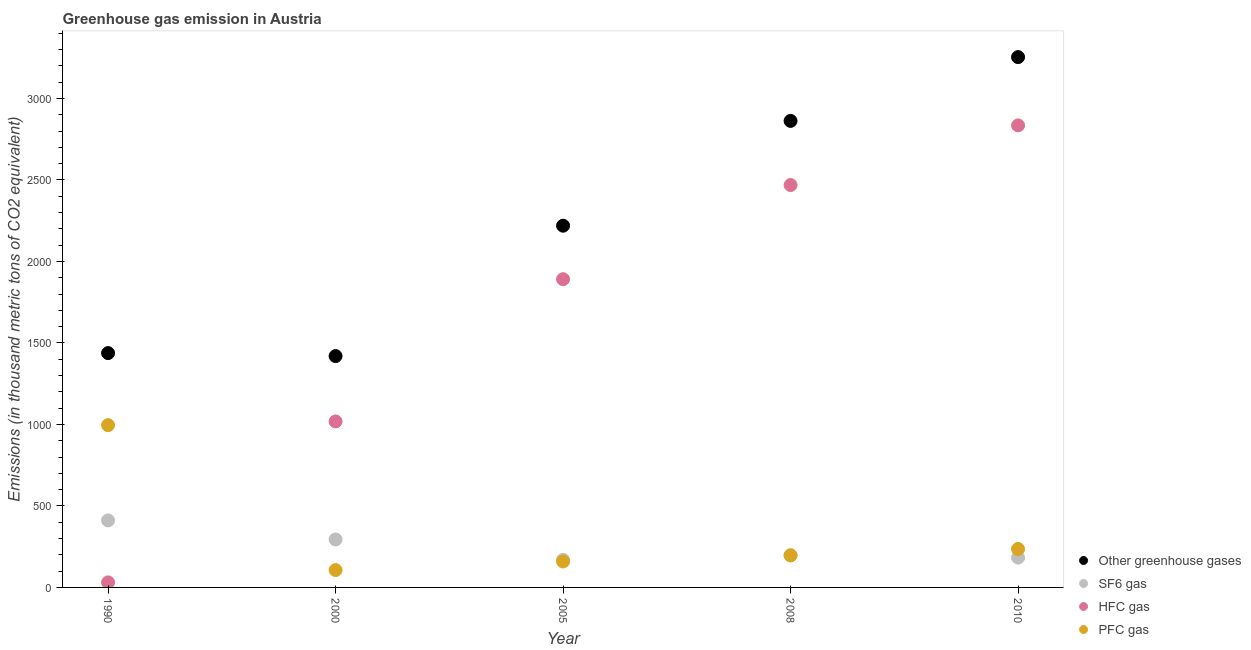What is the emission of sf6 gas in 2010?
Your answer should be very brief. 183. Across all years, what is the maximum emission of sf6 gas?
Your response must be concise. 411.2. Across all years, what is the minimum emission of hfc gas?
Your response must be concise. 30.9. What is the total emission of greenhouse gases in the graph?
Your answer should be very brief. 1.12e+04. What is the difference between the emission of sf6 gas in 2000 and that in 2005?
Offer a terse response. 125.4. What is the difference between the emission of sf6 gas in 2010 and the emission of hfc gas in 2000?
Your response must be concise. -835.4. What is the average emission of greenhouse gases per year?
Ensure brevity in your answer.  2238.64. In the year 2000, what is the difference between the emission of sf6 gas and emission of pfc gas?
Your response must be concise. 187.7. In how many years, is the emission of pfc gas greater than 2500 thousand metric tons?
Offer a very short reply. 0. What is the ratio of the emission of sf6 gas in 1990 to that in 2010?
Provide a succinct answer. 2.25. Is the difference between the emission of sf6 gas in 2008 and 2010 greater than the difference between the emission of hfc gas in 2008 and 2010?
Keep it short and to the point. Yes. What is the difference between the highest and the second highest emission of pfc gas?
Provide a short and direct response. 759.7. What is the difference between the highest and the lowest emission of hfc gas?
Provide a short and direct response. 2804.1. Is the sum of the emission of hfc gas in 2000 and 2005 greater than the maximum emission of greenhouse gases across all years?
Your response must be concise. No. Is it the case that in every year, the sum of the emission of greenhouse gases and emission of sf6 gas is greater than the emission of hfc gas?
Ensure brevity in your answer.  Yes. Does the emission of sf6 gas monotonically increase over the years?
Provide a succinct answer. No. Is the emission of hfc gas strictly less than the emission of pfc gas over the years?
Your response must be concise. No. How many dotlines are there?
Your answer should be very brief. 4. How many years are there in the graph?
Give a very brief answer. 5. Are the values on the major ticks of Y-axis written in scientific E-notation?
Ensure brevity in your answer.  No. How many legend labels are there?
Offer a terse response. 4. What is the title of the graph?
Your answer should be compact. Greenhouse gas emission in Austria. What is the label or title of the X-axis?
Your answer should be compact. Year. What is the label or title of the Y-axis?
Give a very brief answer. Emissions (in thousand metric tons of CO2 equivalent). What is the Emissions (in thousand metric tons of CO2 equivalent) of Other greenhouse gases in 1990?
Give a very brief answer. 1437.8. What is the Emissions (in thousand metric tons of CO2 equivalent) of SF6 gas in 1990?
Keep it short and to the point. 411.2. What is the Emissions (in thousand metric tons of CO2 equivalent) in HFC gas in 1990?
Offer a very short reply. 30.9. What is the Emissions (in thousand metric tons of CO2 equivalent) in PFC gas in 1990?
Give a very brief answer. 995.7. What is the Emissions (in thousand metric tons of CO2 equivalent) of Other greenhouse gases in 2000?
Provide a succinct answer. 1419.5. What is the Emissions (in thousand metric tons of CO2 equivalent) in SF6 gas in 2000?
Offer a very short reply. 294.4. What is the Emissions (in thousand metric tons of CO2 equivalent) of HFC gas in 2000?
Offer a terse response. 1018.4. What is the Emissions (in thousand metric tons of CO2 equivalent) of PFC gas in 2000?
Offer a very short reply. 106.7. What is the Emissions (in thousand metric tons of CO2 equivalent) in Other greenhouse gases in 2005?
Offer a terse response. 2219.5. What is the Emissions (in thousand metric tons of CO2 equivalent) in SF6 gas in 2005?
Make the answer very short. 169. What is the Emissions (in thousand metric tons of CO2 equivalent) in HFC gas in 2005?
Your response must be concise. 1891.2. What is the Emissions (in thousand metric tons of CO2 equivalent) in PFC gas in 2005?
Provide a succinct answer. 159.3. What is the Emissions (in thousand metric tons of CO2 equivalent) of Other greenhouse gases in 2008?
Offer a very short reply. 2862.4. What is the Emissions (in thousand metric tons of CO2 equivalent) in SF6 gas in 2008?
Make the answer very short. 196.4. What is the Emissions (in thousand metric tons of CO2 equivalent) in HFC gas in 2008?
Offer a terse response. 2468.9. What is the Emissions (in thousand metric tons of CO2 equivalent) of PFC gas in 2008?
Make the answer very short. 197.1. What is the Emissions (in thousand metric tons of CO2 equivalent) of Other greenhouse gases in 2010?
Provide a succinct answer. 3254. What is the Emissions (in thousand metric tons of CO2 equivalent) of SF6 gas in 2010?
Your answer should be very brief. 183. What is the Emissions (in thousand metric tons of CO2 equivalent) of HFC gas in 2010?
Provide a succinct answer. 2835. What is the Emissions (in thousand metric tons of CO2 equivalent) of PFC gas in 2010?
Provide a succinct answer. 236. Across all years, what is the maximum Emissions (in thousand metric tons of CO2 equivalent) in Other greenhouse gases?
Provide a succinct answer. 3254. Across all years, what is the maximum Emissions (in thousand metric tons of CO2 equivalent) of SF6 gas?
Give a very brief answer. 411.2. Across all years, what is the maximum Emissions (in thousand metric tons of CO2 equivalent) in HFC gas?
Keep it short and to the point. 2835. Across all years, what is the maximum Emissions (in thousand metric tons of CO2 equivalent) of PFC gas?
Offer a very short reply. 995.7. Across all years, what is the minimum Emissions (in thousand metric tons of CO2 equivalent) in Other greenhouse gases?
Your response must be concise. 1419.5. Across all years, what is the minimum Emissions (in thousand metric tons of CO2 equivalent) in SF6 gas?
Make the answer very short. 169. Across all years, what is the minimum Emissions (in thousand metric tons of CO2 equivalent) in HFC gas?
Your response must be concise. 30.9. Across all years, what is the minimum Emissions (in thousand metric tons of CO2 equivalent) of PFC gas?
Offer a terse response. 106.7. What is the total Emissions (in thousand metric tons of CO2 equivalent) of Other greenhouse gases in the graph?
Your answer should be very brief. 1.12e+04. What is the total Emissions (in thousand metric tons of CO2 equivalent) in SF6 gas in the graph?
Give a very brief answer. 1254. What is the total Emissions (in thousand metric tons of CO2 equivalent) of HFC gas in the graph?
Provide a succinct answer. 8244.4. What is the total Emissions (in thousand metric tons of CO2 equivalent) of PFC gas in the graph?
Provide a succinct answer. 1694.8. What is the difference between the Emissions (in thousand metric tons of CO2 equivalent) of SF6 gas in 1990 and that in 2000?
Provide a short and direct response. 116.8. What is the difference between the Emissions (in thousand metric tons of CO2 equivalent) in HFC gas in 1990 and that in 2000?
Provide a short and direct response. -987.5. What is the difference between the Emissions (in thousand metric tons of CO2 equivalent) of PFC gas in 1990 and that in 2000?
Your answer should be very brief. 889. What is the difference between the Emissions (in thousand metric tons of CO2 equivalent) in Other greenhouse gases in 1990 and that in 2005?
Make the answer very short. -781.7. What is the difference between the Emissions (in thousand metric tons of CO2 equivalent) of SF6 gas in 1990 and that in 2005?
Your answer should be very brief. 242.2. What is the difference between the Emissions (in thousand metric tons of CO2 equivalent) of HFC gas in 1990 and that in 2005?
Provide a short and direct response. -1860.3. What is the difference between the Emissions (in thousand metric tons of CO2 equivalent) in PFC gas in 1990 and that in 2005?
Make the answer very short. 836.4. What is the difference between the Emissions (in thousand metric tons of CO2 equivalent) of Other greenhouse gases in 1990 and that in 2008?
Your response must be concise. -1424.6. What is the difference between the Emissions (in thousand metric tons of CO2 equivalent) of SF6 gas in 1990 and that in 2008?
Offer a very short reply. 214.8. What is the difference between the Emissions (in thousand metric tons of CO2 equivalent) of HFC gas in 1990 and that in 2008?
Offer a very short reply. -2438. What is the difference between the Emissions (in thousand metric tons of CO2 equivalent) of PFC gas in 1990 and that in 2008?
Your answer should be compact. 798.6. What is the difference between the Emissions (in thousand metric tons of CO2 equivalent) of Other greenhouse gases in 1990 and that in 2010?
Make the answer very short. -1816.2. What is the difference between the Emissions (in thousand metric tons of CO2 equivalent) in SF6 gas in 1990 and that in 2010?
Keep it short and to the point. 228.2. What is the difference between the Emissions (in thousand metric tons of CO2 equivalent) in HFC gas in 1990 and that in 2010?
Offer a very short reply. -2804.1. What is the difference between the Emissions (in thousand metric tons of CO2 equivalent) in PFC gas in 1990 and that in 2010?
Your answer should be compact. 759.7. What is the difference between the Emissions (in thousand metric tons of CO2 equivalent) in Other greenhouse gases in 2000 and that in 2005?
Keep it short and to the point. -800. What is the difference between the Emissions (in thousand metric tons of CO2 equivalent) in SF6 gas in 2000 and that in 2005?
Provide a succinct answer. 125.4. What is the difference between the Emissions (in thousand metric tons of CO2 equivalent) of HFC gas in 2000 and that in 2005?
Provide a short and direct response. -872.8. What is the difference between the Emissions (in thousand metric tons of CO2 equivalent) in PFC gas in 2000 and that in 2005?
Provide a succinct answer. -52.6. What is the difference between the Emissions (in thousand metric tons of CO2 equivalent) of Other greenhouse gases in 2000 and that in 2008?
Keep it short and to the point. -1442.9. What is the difference between the Emissions (in thousand metric tons of CO2 equivalent) of HFC gas in 2000 and that in 2008?
Ensure brevity in your answer.  -1450.5. What is the difference between the Emissions (in thousand metric tons of CO2 equivalent) of PFC gas in 2000 and that in 2008?
Provide a short and direct response. -90.4. What is the difference between the Emissions (in thousand metric tons of CO2 equivalent) in Other greenhouse gases in 2000 and that in 2010?
Your answer should be very brief. -1834.5. What is the difference between the Emissions (in thousand metric tons of CO2 equivalent) of SF6 gas in 2000 and that in 2010?
Make the answer very short. 111.4. What is the difference between the Emissions (in thousand metric tons of CO2 equivalent) in HFC gas in 2000 and that in 2010?
Provide a short and direct response. -1816.6. What is the difference between the Emissions (in thousand metric tons of CO2 equivalent) of PFC gas in 2000 and that in 2010?
Offer a terse response. -129.3. What is the difference between the Emissions (in thousand metric tons of CO2 equivalent) in Other greenhouse gases in 2005 and that in 2008?
Your answer should be compact. -642.9. What is the difference between the Emissions (in thousand metric tons of CO2 equivalent) of SF6 gas in 2005 and that in 2008?
Make the answer very short. -27.4. What is the difference between the Emissions (in thousand metric tons of CO2 equivalent) of HFC gas in 2005 and that in 2008?
Your answer should be compact. -577.7. What is the difference between the Emissions (in thousand metric tons of CO2 equivalent) in PFC gas in 2005 and that in 2008?
Provide a short and direct response. -37.8. What is the difference between the Emissions (in thousand metric tons of CO2 equivalent) in Other greenhouse gases in 2005 and that in 2010?
Your answer should be compact. -1034.5. What is the difference between the Emissions (in thousand metric tons of CO2 equivalent) of SF6 gas in 2005 and that in 2010?
Make the answer very short. -14. What is the difference between the Emissions (in thousand metric tons of CO2 equivalent) of HFC gas in 2005 and that in 2010?
Offer a terse response. -943.8. What is the difference between the Emissions (in thousand metric tons of CO2 equivalent) of PFC gas in 2005 and that in 2010?
Your response must be concise. -76.7. What is the difference between the Emissions (in thousand metric tons of CO2 equivalent) in Other greenhouse gases in 2008 and that in 2010?
Offer a terse response. -391.6. What is the difference between the Emissions (in thousand metric tons of CO2 equivalent) of HFC gas in 2008 and that in 2010?
Give a very brief answer. -366.1. What is the difference between the Emissions (in thousand metric tons of CO2 equivalent) in PFC gas in 2008 and that in 2010?
Your response must be concise. -38.9. What is the difference between the Emissions (in thousand metric tons of CO2 equivalent) in Other greenhouse gases in 1990 and the Emissions (in thousand metric tons of CO2 equivalent) in SF6 gas in 2000?
Make the answer very short. 1143.4. What is the difference between the Emissions (in thousand metric tons of CO2 equivalent) of Other greenhouse gases in 1990 and the Emissions (in thousand metric tons of CO2 equivalent) of HFC gas in 2000?
Keep it short and to the point. 419.4. What is the difference between the Emissions (in thousand metric tons of CO2 equivalent) in Other greenhouse gases in 1990 and the Emissions (in thousand metric tons of CO2 equivalent) in PFC gas in 2000?
Your answer should be compact. 1331.1. What is the difference between the Emissions (in thousand metric tons of CO2 equivalent) of SF6 gas in 1990 and the Emissions (in thousand metric tons of CO2 equivalent) of HFC gas in 2000?
Give a very brief answer. -607.2. What is the difference between the Emissions (in thousand metric tons of CO2 equivalent) of SF6 gas in 1990 and the Emissions (in thousand metric tons of CO2 equivalent) of PFC gas in 2000?
Provide a short and direct response. 304.5. What is the difference between the Emissions (in thousand metric tons of CO2 equivalent) in HFC gas in 1990 and the Emissions (in thousand metric tons of CO2 equivalent) in PFC gas in 2000?
Your response must be concise. -75.8. What is the difference between the Emissions (in thousand metric tons of CO2 equivalent) of Other greenhouse gases in 1990 and the Emissions (in thousand metric tons of CO2 equivalent) of SF6 gas in 2005?
Provide a short and direct response. 1268.8. What is the difference between the Emissions (in thousand metric tons of CO2 equivalent) of Other greenhouse gases in 1990 and the Emissions (in thousand metric tons of CO2 equivalent) of HFC gas in 2005?
Make the answer very short. -453.4. What is the difference between the Emissions (in thousand metric tons of CO2 equivalent) in Other greenhouse gases in 1990 and the Emissions (in thousand metric tons of CO2 equivalent) in PFC gas in 2005?
Offer a terse response. 1278.5. What is the difference between the Emissions (in thousand metric tons of CO2 equivalent) of SF6 gas in 1990 and the Emissions (in thousand metric tons of CO2 equivalent) of HFC gas in 2005?
Ensure brevity in your answer.  -1480. What is the difference between the Emissions (in thousand metric tons of CO2 equivalent) in SF6 gas in 1990 and the Emissions (in thousand metric tons of CO2 equivalent) in PFC gas in 2005?
Keep it short and to the point. 251.9. What is the difference between the Emissions (in thousand metric tons of CO2 equivalent) of HFC gas in 1990 and the Emissions (in thousand metric tons of CO2 equivalent) of PFC gas in 2005?
Provide a short and direct response. -128.4. What is the difference between the Emissions (in thousand metric tons of CO2 equivalent) of Other greenhouse gases in 1990 and the Emissions (in thousand metric tons of CO2 equivalent) of SF6 gas in 2008?
Keep it short and to the point. 1241.4. What is the difference between the Emissions (in thousand metric tons of CO2 equivalent) in Other greenhouse gases in 1990 and the Emissions (in thousand metric tons of CO2 equivalent) in HFC gas in 2008?
Your answer should be very brief. -1031.1. What is the difference between the Emissions (in thousand metric tons of CO2 equivalent) in Other greenhouse gases in 1990 and the Emissions (in thousand metric tons of CO2 equivalent) in PFC gas in 2008?
Offer a very short reply. 1240.7. What is the difference between the Emissions (in thousand metric tons of CO2 equivalent) in SF6 gas in 1990 and the Emissions (in thousand metric tons of CO2 equivalent) in HFC gas in 2008?
Provide a short and direct response. -2057.7. What is the difference between the Emissions (in thousand metric tons of CO2 equivalent) in SF6 gas in 1990 and the Emissions (in thousand metric tons of CO2 equivalent) in PFC gas in 2008?
Keep it short and to the point. 214.1. What is the difference between the Emissions (in thousand metric tons of CO2 equivalent) of HFC gas in 1990 and the Emissions (in thousand metric tons of CO2 equivalent) of PFC gas in 2008?
Give a very brief answer. -166.2. What is the difference between the Emissions (in thousand metric tons of CO2 equivalent) of Other greenhouse gases in 1990 and the Emissions (in thousand metric tons of CO2 equivalent) of SF6 gas in 2010?
Offer a terse response. 1254.8. What is the difference between the Emissions (in thousand metric tons of CO2 equivalent) of Other greenhouse gases in 1990 and the Emissions (in thousand metric tons of CO2 equivalent) of HFC gas in 2010?
Provide a succinct answer. -1397.2. What is the difference between the Emissions (in thousand metric tons of CO2 equivalent) of Other greenhouse gases in 1990 and the Emissions (in thousand metric tons of CO2 equivalent) of PFC gas in 2010?
Provide a succinct answer. 1201.8. What is the difference between the Emissions (in thousand metric tons of CO2 equivalent) in SF6 gas in 1990 and the Emissions (in thousand metric tons of CO2 equivalent) in HFC gas in 2010?
Your answer should be compact. -2423.8. What is the difference between the Emissions (in thousand metric tons of CO2 equivalent) in SF6 gas in 1990 and the Emissions (in thousand metric tons of CO2 equivalent) in PFC gas in 2010?
Give a very brief answer. 175.2. What is the difference between the Emissions (in thousand metric tons of CO2 equivalent) of HFC gas in 1990 and the Emissions (in thousand metric tons of CO2 equivalent) of PFC gas in 2010?
Your response must be concise. -205.1. What is the difference between the Emissions (in thousand metric tons of CO2 equivalent) of Other greenhouse gases in 2000 and the Emissions (in thousand metric tons of CO2 equivalent) of SF6 gas in 2005?
Ensure brevity in your answer.  1250.5. What is the difference between the Emissions (in thousand metric tons of CO2 equivalent) in Other greenhouse gases in 2000 and the Emissions (in thousand metric tons of CO2 equivalent) in HFC gas in 2005?
Ensure brevity in your answer.  -471.7. What is the difference between the Emissions (in thousand metric tons of CO2 equivalent) of Other greenhouse gases in 2000 and the Emissions (in thousand metric tons of CO2 equivalent) of PFC gas in 2005?
Ensure brevity in your answer.  1260.2. What is the difference between the Emissions (in thousand metric tons of CO2 equivalent) in SF6 gas in 2000 and the Emissions (in thousand metric tons of CO2 equivalent) in HFC gas in 2005?
Give a very brief answer. -1596.8. What is the difference between the Emissions (in thousand metric tons of CO2 equivalent) in SF6 gas in 2000 and the Emissions (in thousand metric tons of CO2 equivalent) in PFC gas in 2005?
Offer a terse response. 135.1. What is the difference between the Emissions (in thousand metric tons of CO2 equivalent) in HFC gas in 2000 and the Emissions (in thousand metric tons of CO2 equivalent) in PFC gas in 2005?
Offer a terse response. 859.1. What is the difference between the Emissions (in thousand metric tons of CO2 equivalent) of Other greenhouse gases in 2000 and the Emissions (in thousand metric tons of CO2 equivalent) of SF6 gas in 2008?
Make the answer very short. 1223.1. What is the difference between the Emissions (in thousand metric tons of CO2 equivalent) in Other greenhouse gases in 2000 and the Emissions (in thousand metric tons of CO2 equivalent) in HFC gas in 2008?
Your answer should be very brief. -1049.4. What is the difference between the Emissions (in thousand metric tons of CO2 equivalent) of Other greenhouse gases in 2000 and the Emissions (in thousand metric tons of CO2 equivalent) of PFC gas in 2008?
Offer a terse response. 1222.4. What is the difference between the Emissions (in thousand metric tons of CO2 equivalent) of SF6 gas in 2000 and the Emissions (in thousand metric tons of CO2 equivalent) of HFC gas in 2008?
Your answer should be compact. -2174.5. What is the difference between the Emissions (in thousand metric tons of CO2 equivalent) in SF6 gas in 2000 and the Emissions (in thousand metric tons of CO2 equivalent) in PFC gas in 2008?
Offer a very short reply. 97.3. What is the difference between the Emissions (in thousand metric tons of CO2 equivalent) of HFC gas in 2000 and the Emissions (in thousand metric tons of CO2 equivalent) of PFC gas in 2008?
Make the answer very short. 821.3. What is the difference between the Emissions (in thousand metric tons of CO2 equivalent) of Other greenhouse gases in 2000 and the Emissions (in thousand metric tons of CO2 equivalent) of SF6 gas in 2010?
Your answer should be very brief. 1236.5. What is the difference between the Emissions (in thousand metric tons of CO2 equivalent) of Other greenhouse gases in 2000 and the Emissions (in thousand metric tons of CO2 equivalent) of HFC gas in 2010?
Make the answer very short. -1415.5. What is the difference between the Emissions (in thousand metric tons of CO2 equivalent) in Other greenhouse gases in 2000 and the Emissions (in thousand metric tons of CO2 equivalent) in PFC gas in 2010?
Your answer should be very brief. 1183.5. What is the difference between the Emissions (in thousand metric tons of CO2 equivalent) in SF6 gas in 2000 and the Emissions (in thousand metric tons of CO2 equivalent) in HFC gas in 2010?
Provide a succinct answer. -2540.6. What is the difference between the Emissions (in thousand metric tons of CO2 equivalent) in SF6 gas in 2000 and the Emissions (in thousand metric tons of CO2 equivalent) in PFC gas in 2010?
Make the answer very short. 58.4. What is the difference between the Emissions (in thousand metric tons of CO2 equivalent) in HFC gas in 2000 and the Emissions (in thousand metric tons of CO2 equivalent) in PFC gas in 2010?
Make the answer very short. 782.4. What is the difference between the Emissions (in thousand metric tons of CO2 equivalent) in Other greenhouse gases in 2005 and the Emissions (in thousand metric tons of CO2 equivalent) in SF6 gas in 2008?
Ensure brevity in your answer.  2023.1. What is the difference between the Emissions (in thousand metric tons of CO2 equivalent) of Other greenhouse gases in 2005 and the Emissions (in thousand metric tons of CO2 equivalent) of HFC gas in 2008?
Provide a short and direct response. -249.4. What is the difference between the Emissions (in thousand metric tons of CO2 equivalent) in Other greenhouse gases in 2005 and the Emissions (in thousand metric tons of CO2 equivalent) in PFC gas in 2008?
Keep it short and to the point. 2022.4. What is the difference between the Emissions (in thousand metric tons of CO2 equivalent) in SF6 gas in 2005 and the Emissions (in thousand metric tons of CO2 equivalent) in HFC gas in 2008?
Offer a very short reply. -2299.9. What is the difference between the Emissions (in thousand metric tons of CO2 equivalent) in SF6 gas in 2005 and the Emissions (in thousand metric tons of CO2 equivalent) in PFC gas in 2008?
Provide a succinct answer. -28.1. What is the difference between the Emissions (in thousand metric tons of CO2 equivalent) in HFC gas in 2005 and the Emissions (in thousand metric tons of CO2 equivalent) in PFC gas in 2008?
Your response must be concise. 1694.1. What is the difference between the Emissions (in thousand metric tons of CO2 equivalent) of Other greenhouse gases in 2005 and the Emissions (in thousand metric tons of CO2 equivalent) of SF6 gas in 2010?
Make the answer very short. 2036.5. What is the difference between the Emissions (in thousand metric tons of CO2 equivalent) in Other greenhouse gases in 2005 and the Emissions (in thousand metric tons of CO2 equivalent) in HFC gas in 2010?
Keep it short and to the point. -615.5. What is the difference between the Emissions (in thousand metric tons of CO2 equivalent) of Other greenhouse gases in 2005 and the Emissions (in thousand metric tons of CO2 equivalent) of PFC gas in 2010?
Offer a terse response. 1983.5. What is the difference between the Emissions (in thousand metric tons of CO2 equivalent) in SF6 gas in 2005 and the Emissions (in thousand metric tons of CO2 equivalent) in HFC gas in 2010?
Your answer should be very brief. -2666. What is the difference between the Emissions (in thousand metric tons of CO2 equivalent) in SF6 gas in 2005 and the Emissions (in thousand metric tons of CO2 equivalent) in PFC gas in 2010?
Offer a terse response. -67. What is the difference between the Emissions (in thousand metric tons of CO2 equivalent) of HFC gas in 2005 and the Emissions (in thousand metric tons of CO2 equivalent) of PFC gas in 2010?
Provide a short and direct response. 1655.2. What is the difference between the Emissions (in thousand metric tons of CO2 equivalent) in Other greenhouse gases in 2008 and the Emissions (in thousand metric tons of CO2 equivalent) in SF6 gas in 2010?
Your answer should be compact. 2679.4. What is the difference between the Emissions (in thousand metric tons of CO2 equivalent) in Other greenhouse gases in 2008 and the Emissions (in thousand metric tons of CO2 equivalent) in HFC gas in 2010?
Keep it short and to the point. 27.4. What is the difference between the Emissions (in thousand metric tons of CO2 equivalent) of Other greenhouse gases in 2008 and the Emissions (in thousand metric tons of CO2 equivalent) of PFC gas in 2010?
Provide a succinct answer. 2626.4. What is the difference between the Emissions (in thousand metric tons of CO2 equivalent) of SF6 gas in 2008 and the Emissions (in thousand metric tons of CO2 equivalent) of HFC gas in 2010?
Provide a succinct answer. -2638.6. What is the difference between the Emissions (in thousand metric tons of CO2 equivalent) of SF6 gas in 2008 and the Emissions (in thousand metric tons of CO2 equivalent) of PFC gas in 2010?
Your answer should be compact. -39.6. What is the difference between the Emissions (in thousand metric tons of CO2 equivalent) in HFC gas in 2008 and the Emissions (in thousand metric tons of CO2 equivalent) in PFC gas in 2010?
Your answer should be very brief. 2232.9. What is the average Emissions (in thousand metric tons of CO2 equivalent) of Other greenhouse gases per year?
Your answer should be compact. 2238.64. What is the average Emissions (in thousand metric tons of CO2 equivalent) in SF6 gas per year?
Your answer should be very brief. 250.8. What is the average Emissions (in thousand metric tons of CO2 equivalent) in HFC gas per year?
Offer a very short reply. 1648.88. What is the average Emissions (in thousand metric tons of CO2 equivalent) in PFC gas per year?
Make the answer very short. 338.96. In the year 1990, what is the difference between the Emissions (in thousand metric tons of CO2 equivalent) of Other greenhouse gases and Emissions (in thousand metric tons of CO2 equivalent) of SF6 gas?
Make the answer very short. 1026.6. In the year 1990, what is the difference between the Emissions (in thousand metric tons of CO2 equivalent) in Other greenhouse gases and Emissions (in thousand metric tons of CO2 equivalent) in HFC gas?
Give a very brief answer. 1406.9. In the year 1990, what is the difference between the Emissions (in thousand metric tons of CO2 equivalent) in Other greenhouse gases and Emissions (in thousand metric tons of CO2 equivalent) in PFC gas?
Provide a short and direct response. 442.1. In the year 1990, what is the difference between the Emissions (in thousand metric tons of CO2 equivalent) in SF6 gas and Emissions (in thousand metric tons of CO2 equivalent) in HFC gas?
Offer a very short reply. 380.3. In the year 1990, what is the difference between the Emissions (in thousand metric tons of CO2 equivalent) in SF6 gas and Emissions (in thousand metric tons of CO2 equivalent) in PFC gas?
Provide a succinct answer. -584.5. In the year 1990, what is the difference between the Emissions (in thousand metric tons of CO2 equivalent) of HFC gas and Emissions (in thousand metric tons of CO2 equivalent) of PFC gas?
Ensure brevity in your answer.  -964.8. In the year 2000, what is the difference between the Emissions (in thousand metric tons of CO2 equivalent) of Other greenhouse gases and Emissions (in thousand metric tons of CO2 equivalent) of SF6 gas?
Your answer should be compact. 1125.1. In the year 2000, what is the difference between the Emissions (in thousand metric tons of CO2 equivalent) of Other greenhouse gases and Emissions (in thousand metric tons of CO2 equivalent) of HFC gas?
Provide a short and direct response. 401.1. In the year 2000, what is the difference between the Emissions (in thousand metric tons of CO2 equivalent) in Other greenhouse gases and Emissions (in thousand metric tons of CO2 equivalent) in PFC gas?
Offer a terse response. 1312.8. In the year 2000, what is the difference between the Emissions (in thousand metric tons of CO2 equivalent) in SF6 gas and Emissions (in thousand metric tons of CO2 equivalent) in HFC gas?
Provide a succinct answer. -724. In the year 2000, what is the difference between the Emissions (in thousand metric tons of CO2 equivalent) of SF6 gas and Emissions (in thousand metric tons of CO2 equivalent) of PFC gas?
Provide a short and direct response. 187.7. In the year 2000, what is the difference between the Emissions (in thousand metric tons of CO2 equivalent) in HFC gas and Emissions (in thousand metric tons of CO2 equivalent) in PFC gas?
Provide a short and direct response. 911.7. In the year 2005, what is the difference between the Emissions (in thousand metric tons of CO2 equivalent) in Other greenhouse gases and Emissions (in thousand metric tons of CO2 equivalent) in SF6 gas?
Ensure brevity in your answer.  2050.5. In the year 2005, what is the difference between the Emissions (in thousand metric tons of CO2 equivalent) of Other greenhouse gases and Emissions (in thousand metric tons of CO2 equivalent) of HFC gas?
Keep it short and to the point. 328.3. In the year 2005, what is the difference between the Emissions (in thousand metric tons of CO2 equivalent) of Other greenhouse gases and Emissions (in thousand metric tons of CO2 equivalent) of PFC gas?
Your response must be concise. 2060.2. In the year 2005, what is the difference between the Emissions (in thousand metric tons of CO2 equivalent) of SF6 gas and Emissions (in thousand metric tons of CO2 equivalent) of HFC gas?
Your response must be concise. -1722.2. In the year 2005, what is the difference between the Emissions (in thousand metric tons of CO2 equivalent) in SF6 gas and Emissions (in thousand metric tons of CO2 equivalent) in PFC gas?
Provide a succinct answer. 9.7. In the year 2005, what is the difference between the Emissions (in thousand metric tons of CO2 equivalent) of HFC gas and Emissions (in thousand metric tons of CO2 equivalent) of PFC gas?
Provide a short and direct response. 1731.9. In the year 2008, what is the difference between the Emissions (in thousand metric tons of CO2 equivalent) of Other greenhouse gases and Emissions (in thousand metric tons of CO2 equivalent) of SF6 gas?
Your response must be concise. 2666. In the year 2008, what is the difference between the Emissions (in thousand metric tons of CO2 equivalent) in Other greenhouse gases and Emissions (in thousand metric tons of CO2 equivalent) in HFC gas?
Your response must be concise. 393.5. In the year 2008, what is the difference between the Emissions (in thousand metric tons of CO2 equivalent) of Other greenhouse gases and Emissions (in thousand metric tons of CO2 equivalent) of PFC gas?
Provide a succinct answer. 2665.3. In the year 2008, what is the difference between the Emissions (in thousand metric tons of CO2 equivalent) in SF6 gas and Emissions (in thousand metric tons of CO2 equivalent) in HFC gas?
Ensure brevity in your answer.  -2272.5. In the year 2008, what is the difference between the Emissions (in thousand metric tons of CO2 equivalent) of SF6 gas and Emissions (in thousand metric tons of CO2 equivalent) of PFC gas?
Your response must be concise. -0.7. In the year 2008, what is the difference between the Emissions (in thousand metric tons of CO2 equivalent) of HFC gas and Emissions (in thousand metric tons of CO2 equivalent) of PFC gas?
Your response must be concise. 2271.8. In the year 2010, what is the difference between the Emissions (in thousand metric tons of CO2 equivalent) in Other greenhouse gases and Emissions (in thousand metric tons of CO2 equivalent) in SF6 gas?
Your answer should be compact. 3071. In the year 2010, what is the difference between the Emissions (in thousand metric tons of CO2 equivalent) of Other greenhouse gases and Emissions (in thousand metric tons of CO2 equivalent) of HFC gas?
Your answer should be compact. 419. In the year 2010, what is the difference between the Emissions (in thousand metric tons of CO2 equivalent) in Other greenhouse gases and Emissions (in thousand metric tons of CO2 equivalent) in PFC gas?
Provide a succinct answer. 3018. In the year 2010, what is the difference between the Emissions (in thousand metric tons of CO2 equivalent) in SF6 gas and Emissions (in thousand metric tons of CO2 equivalent) in HFC gas?
Your response must be concise. -2652. In the year 2010, what is the difference between the Emissions (in thousand metric tons of CO2 equivalent) in SF6 gas and Emissions (in thousand metric tons of CO2 equivalent) in PFC gas?
Your answer should be compact. -53. In the year 2010, what is the difference between the Emissions (in thousand metric tons of CO2 equivalent) in HFC gas and Emissions (in thousand metric tons of CO2 equivalent) in PFC gas?
Your answer should be compact. 2599. What is the ratio of the Emissions (in thousand metric tons of CO2 equivalent) in Other greenhouse gases in 1990 to that in 2000?
Give a very brief answer. 1.01. What is the ratio of the Emissions (in thousand metric tons of CO2 equivalent) in SF6 gas in 1990 to that in 2000?
Your response must be concise. 1.4. What is the ratio of the Emissions (in thousand metric tons of CO2 equivalent) of HFC gas in 1990 to that in 2000?
Your answer should be very brief. 0.03. What is the ratio of the Emissions (in thousand metric tons of CO2 equivalent) in PFC gas in 1990 to that in 2000?
Provide a succinct answer. 9.33. What is the ratio of the Emissions (in thousand metric tons of CO2 equivalent) in Other greenhouse gases in 1990 to that in 2005?
Your answer should be very brief. 0.65. What is the ratio of the Emissions (in thousand metric tons of CO2 equivalent) of SF6 gas in 1990 to that in 2005?
Make the answer very short. 2.43. What is the ratio of the Emissions (in thousand metric tons of CO2 equivalent) of HFC gas in 1990 to that in 2005?
Make the answer very short. 0.02. What is the ratio of the Emissions (in thousand metric tons of CO2 equivalent) in PFC gas in 1990 to that in 2005?
Ensure brevity in your answer.  6.25. What is the ratio of the Emissions (in thousand metric tons of CO2 equivalent) of Other greenhouse gases in 1990 to that in 2008?
Your answer should be compact. 0.5. What is the ratio of the Emissions (in thousand metric tons of CO2 equivalent) of SF6 gas in 1990 to that in 2008?
Keep it short and to the point. 2.09. What is the ratio of the Emissions (in thousand metric tons of CO2 equivalent) of HFC gas in 1990 to that in 2008?
Give a very brief answer. 0.01. What is the ratio of the Emissions (in thousand metric tons of CO2 equivalent) in PFC gas in 1990 to that in 2008?
Your answer should be very brief. 5.05. What is the ratio of the Emissions (in thousand metric tons of CO2 equivalent) in Other greenhouse gases in 1990 to that in 2010?
Your answer should be very brief. 0.44. What is the ratio of the Emissions (in thousand metric tons of CO2 equivalent) of SF6 gas in 1990 to that in 2010?
Your response must be concise. 2.25. What is the ratio of the Emissions (in thousand metric tons of CO2 equivalent) in HFC gas in 1990 to that in 2010?
Offer a terse response. 0.01. What is the ratio of the Emissions (in thousand metric tons of CO2 equivalent) in PFC gas in 1990 to that in 2010?
Make the answer very short. 4.22. What is the ratio of the Emissions (in thousand metric tons of CO2 equivalent) of Other greenhouse gases in 2000 to that in 2005?
Your answer should be very brief. 0.64. What is the ratio of the Emissions (in thousand metric tons of CO2 equivalent) in SF6 gas in 2000 to that in 2005?
Provide a short and direct response. 1.74. What is the ratio of the Emissions (in thousand metric tons of CO2 equivalent) in HFC gas in 2000 to that in 2005?
Give a very brief answer. 0.54. What is the ratio of the Emissions (in thousand metric tons of CO2 equivalent) in PFC gas in 2000 to that in 2005?
Make the answer very short. 0.67. What is the ratio of the Emissions (in thousand metric tons of CO2 equivalent) of Other greenhouse gases in 2000 to that in 2008?
Keep it short and to the point. 0.5. What is the ratio of the Emissions (in thousand metric tons of CO2 equivalent) in SF6 gas in 2000 to that in 2008?
Offer a very short reply. 1.5. What is the ratio of the Emissions (in thousand metric tons of CO2 equivalent) of HFC gas in 2000 to that in 2008?
Your answer should be compact. 0.41. What is the ratio of the Emissions (in thousand metric tons of CO2 equivalent) in PFC gas in 2000 to that in 2008?
Your response must be concise. 0.54. What is the ratio of the Emissions (in thousand metric tons of CO2 equivalent) in Other greenhouse gases in 2000 to that in 2010?
Keep it short and to the point. 0.44. What is the ratio of the Emissions (in thousand metric tons of CO2 equivalent) of SF6 gas in 2000 to that in 2010?
Your answer should be very brief. 1.61. What is the ratio of the Emissions (in thousand metric tons of CO2 equivalent) of HFC gas in 2000 to that in 2010?
Offer a terse response. 0.36. What is the ratio of the Emissions (in thousand metric tons of CO2 equivalent) of PFC gas in 2000 to that in 2010?
Your answer should be very brief. 0.45. What is the ratio of the Emissions (in thousand metric tons of CO2 equivalent) of Other greenhouse gases in 2005 to that in 2008?
Keep it short and to the point. 0.78. What is the ratio of the Emissions (in thousand metric tons of CO2 equivalent) of SF6 gas in 2005 to that in 2008?
Offer a terse response. 0.86. What is the ratio of the Emissions (in thousand metric tons of CO2 equivalent) in HFC gas in 2005 to that in 2008?
Your answer should be very brief. 0.77. What is the ratio of the Emissions (in thousand metric tons of CO2 equivalent) of PFC gas in 2005 to that in 2008?
Provide a short and direct response. 0.81. What is the ratio of the Emissions (in thousand metric tons of CO2 equivalent) in Other greenhouse gases in 2005 to that in 2010?
Your response must be concise. 0.68. What is the ratio of the Emissions (in thousand metric tons of CO2 equivalent) of SF6 gas in 2005 to that in 2010?
Give a very brief answer. 0.92. What is the ratio of the Emissions (in thousand metric tons of CO2 equivalent) of HFC gas in 2005 to that in 2010?
Give a very brief answer. 0.67. What is the ratio of the Emissions (in thousand metric tons of CO2 equivalent) in PFC gas in 2005 to that in 2010?
Your answer should be compact. 0.68. What is the ratio of the Emissions (in thousand metric tons of CO2 equivalent) in Other greenhouse gases in 2008 to that in 2010?
Make the answer very short. 0.88. What is the ratio of the Emissions (in thousand metric tons of CO2 equivalent) in SF6 gas in 2008 to that in 2010?
Provide a succinct answer. 1.07. What is the ratio of the Emissions (in thousand metric tons of CO2 equivalent) of HFC gas in 2008 to that in 2010?
Provide a succinct answer. 0.87. What is the ratio of the Emissions (in thousand metric tons of CO2 equivalent) in PFC gas in 2008 to that in 2010?
Your answer should be compact. 0.84. What is the difference between the highest and the second highest Emissions (in thousand metric tons of CO2 equivalent) in Other greenhouse gases?
Offer a terse response. 391.6. What is the difference between the highest and the second highest Emissions (in thousand metric tons of CO2 equivalent) of SF6 gas?
Your answer should be very brief. 116.8. What is the difference between the highest and the second highest Emissions (in thousand metric tons of CO2 equivalent) of HFC gas?
Give a very brief answer. 366.1. What is the difference between the highest and the second highest Emissions (in thousand metric tons of CO2 equivalent) of PFC gas?
Ensure brevity in your answer.  759.7. What is the difference between the highest and the lowest Emissions (in thousand metric tons of CO2 equivalent) of Other greenhouse gases?
Your answer should be compact. 1834.5. What is the difference between the highest and the lowest Emissions (in thousand metric tons of CO2 equivalent) in SF6 gas?
Provide a short and direct response. 242.2. What is the difference between the highest and the lowest Emissions (in thousand metric tons of CO2 equivalent) in HFC gas?
Your answer should be very brief. 2804.1. What is the difference between the highest and the lowest Emissions (in thousand metric tons of CO2 equivalent) of PFC gas?
Make the answer very short. 889. 